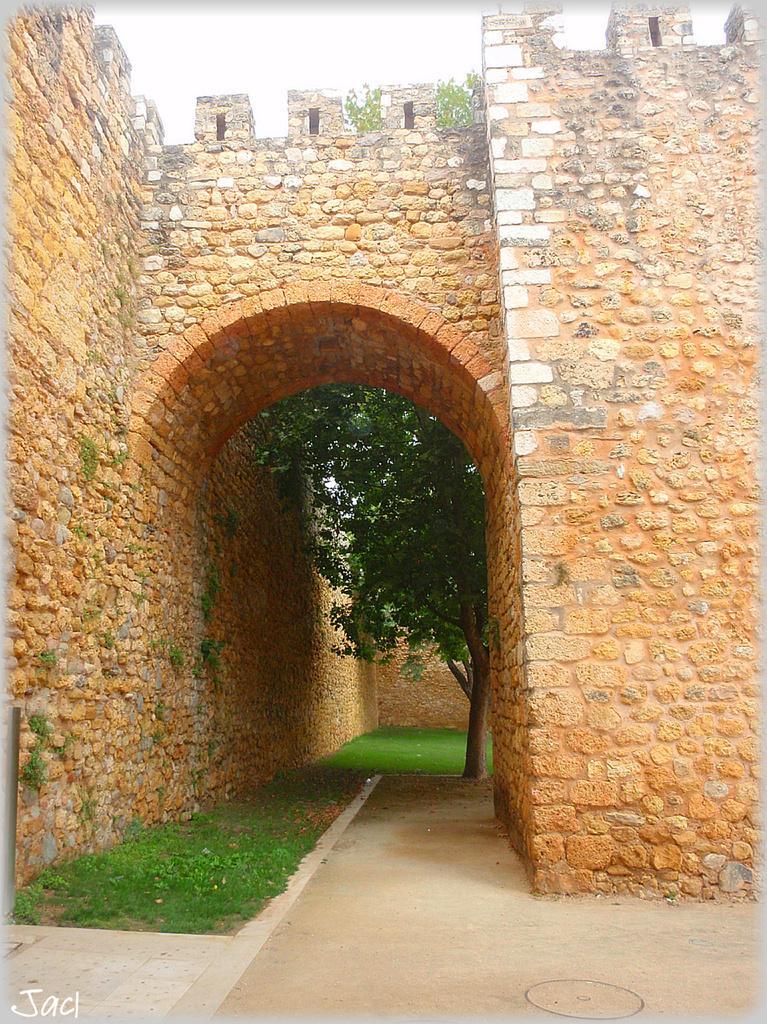Could you give a brief overview of what you see in this image? In this image we can see stone arch, grass, stone wall, trees and the sky in the background. Here we can see the watermark. 